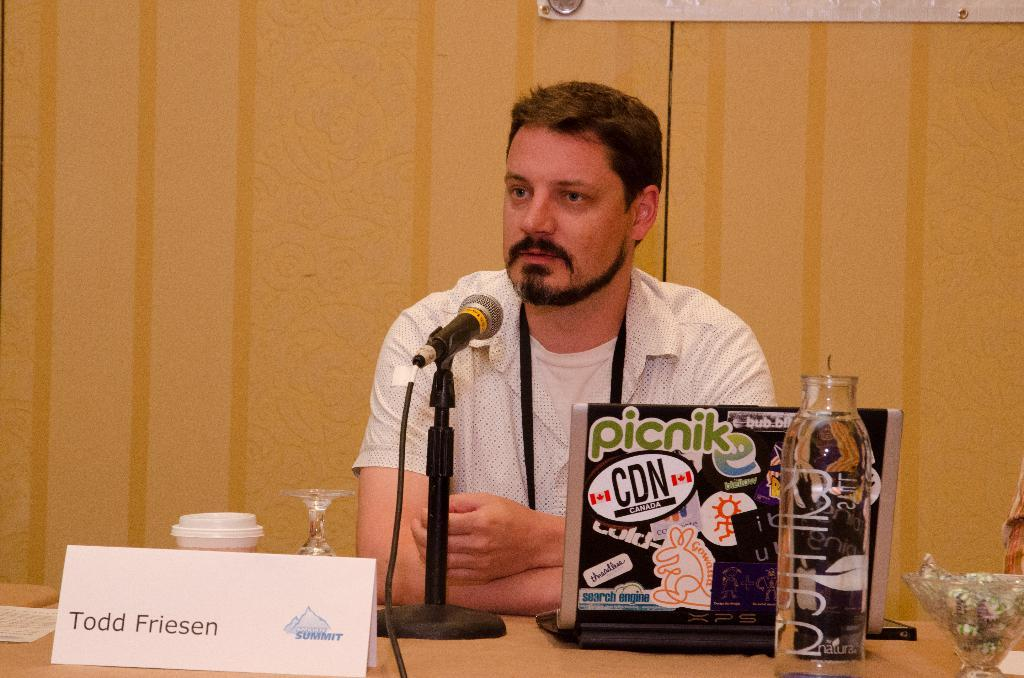Who is the main subject in the image? There is a person in the center of the image. What is the person doing in the image? The person is looking at someone. What type of furniture is in the image? There is a wooden table in the image. What items can be seen on the table? A bottle, a microphone, a glass, and a glass bowl are on the table. How many chickens are present in the image? A: There are no chickens present in the image. Is there a kitty playing with the microphone on the table? There is no kitty present in the image, and therefore it cannot be playing with the microphone. 